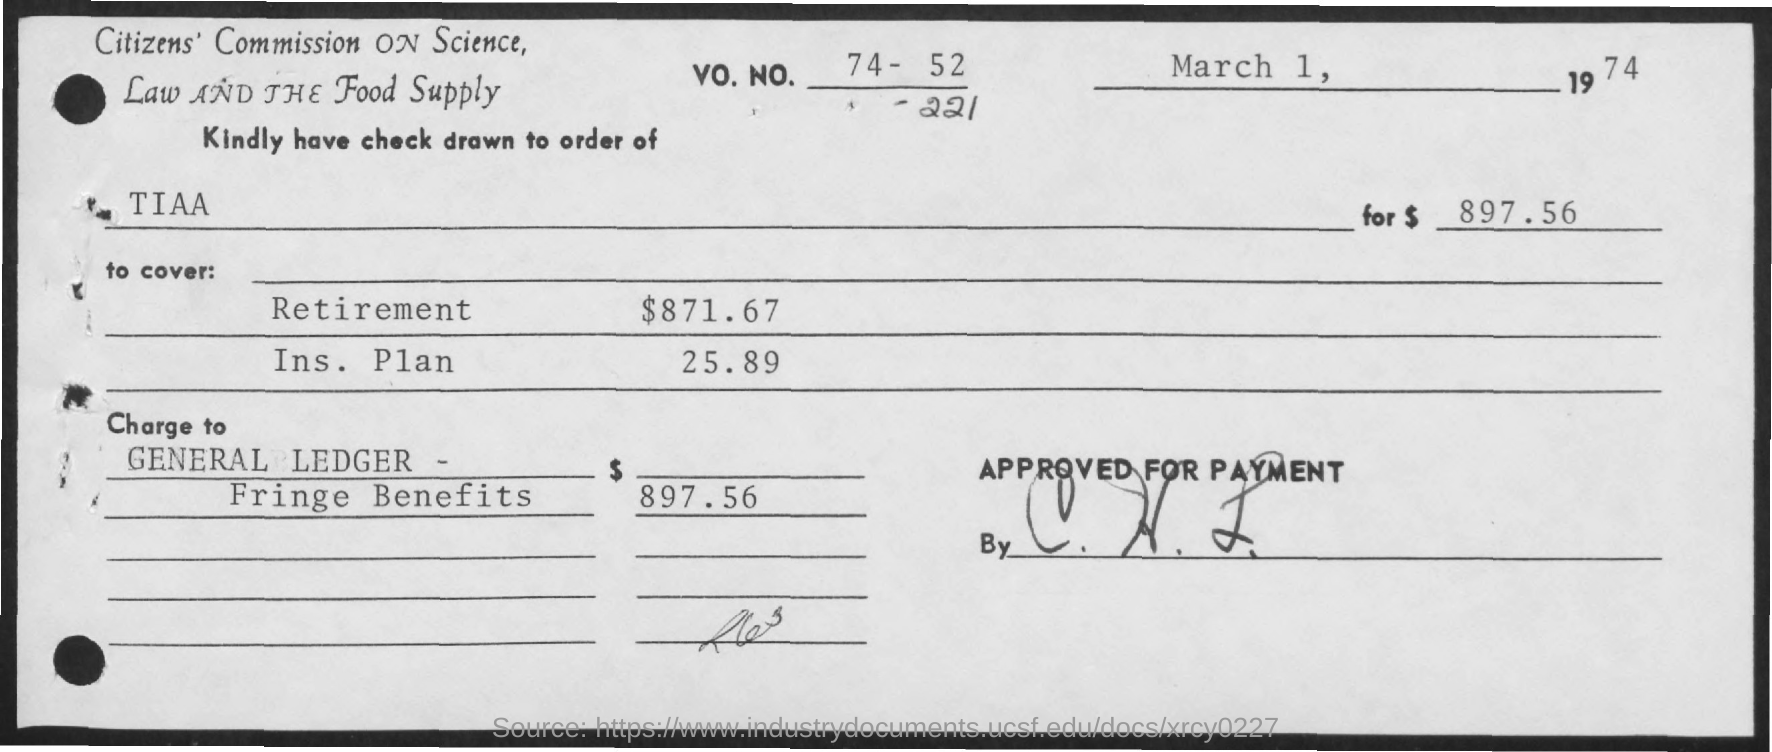Kindly have check drawn to order of whom?
Provide a short and direct response. TIAA. What is the total amount mentioned ?
Your answer should be compact. $ 897.56. How much  amount is to cover for retirement
Offer a very short reply. $871.67. How much  amount is to cover for ins . plan
Provide a short and direct response. 25.89. 